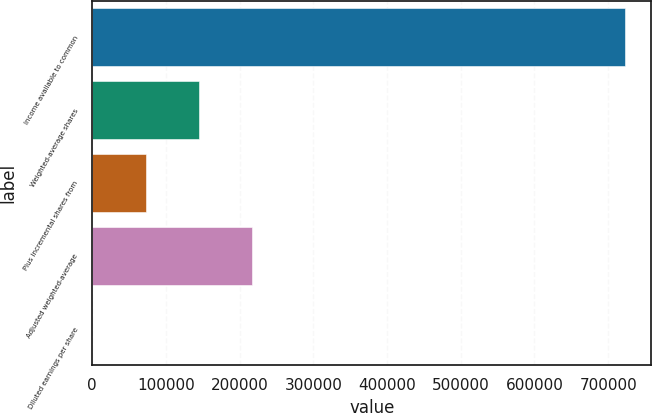Convert chart to OTSL. <chart><loc_0><loc_0><loc_500><loc_500><bar_chart><fcel>Income available to common<fcel>Weighted-average shares<fcel>Plus incremental shares from<fcel>Adjusted weighted-average<fcel>Diluted earnings per share<nl><fcel>722521<fcel>144509<fcel>72257.5<fcel>216760<fcel>6<nl></chart> 